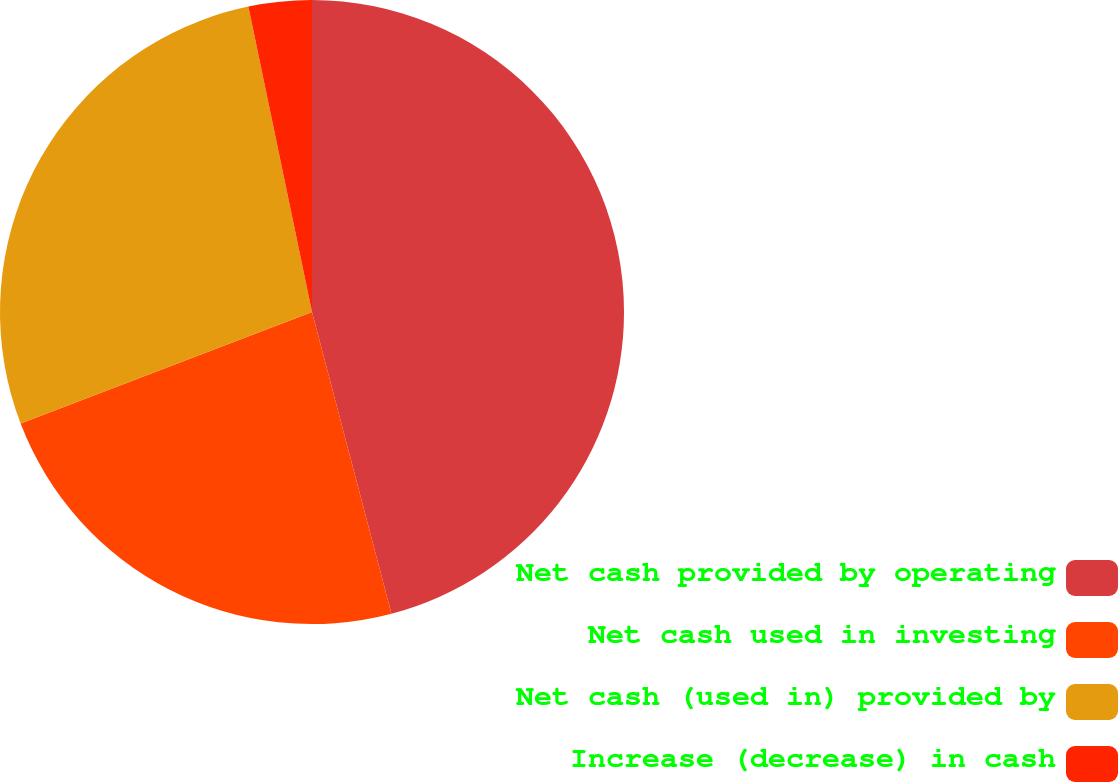Convert chart. <chart><loc_0><loc_0><loc_500><loc_500><pie_chart><fcel>Net cash provided by operating<fcel>Net cash used in investing<fcel>Net cash (used in) provided by<fcel>Increase (decrease) in cash<nl><fcel>45.9%<fcel>23.28%<fcel>27.55%<fcel>3.27%<nl></chart> 